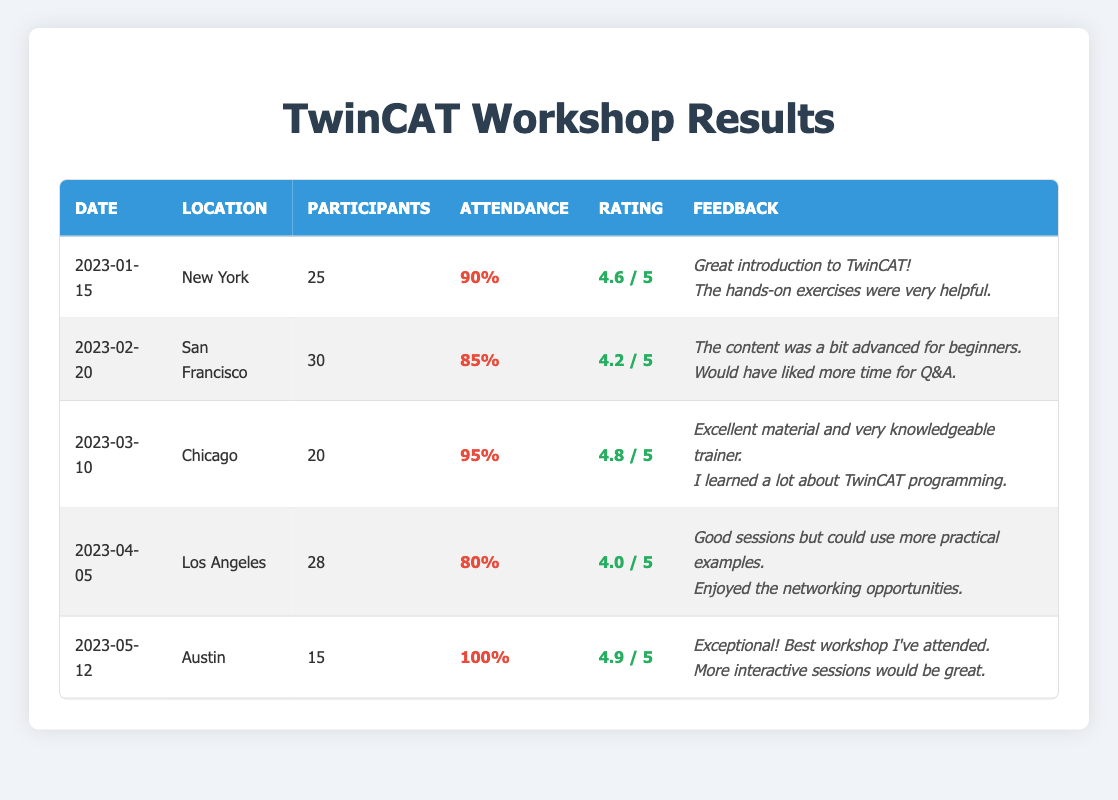What was the attendance rate for the workshop held in New York? The attendance rate for the New York workshop on January 15, 2023, is listed in the table as 90%.
Answer: 90% Which workshop had the highest average rating? The average ratings for each workshop are compared, and the Chicago workshop on March 10, 2023, has the highest rating of 4.8.
Answer: 4.8 How many participants attended the workshop in Austin? The table shows that the Austin workshop on May 12, 2023, had 15 participants.
Answer: 15 Is the attendance rate for the Los Angeles workshop higher than 80%? The attendance rate for the Los Angeles workshop is listed as 80%, which means it is not higher than 80%.
Answer: No What is the average rating of all the workshops combined? The ratings are as follows: 4.6, 4.2, 4.8, 4.0, and 4.9. The sum is 4.6 + 4.2 + 4.8 + 4.0 + 4.9 = 22.5. There are 5 workshops, so the average is 22.5 / 5 = 4.5.
Answer: 4.5 What percentage of the Austin workshop participants attended? The attendance rate for the Austin workshop is 100%, meaning all participants who registered attended the workshop.
Answer: 100% Which workshop had the least number of participants? The table shows that the Austin workshop had the least number of participants with only 15 attendees.
Answer: Austin How many feedback comments were provided for the Chicago workshop? The Chicago workshop has two feedback comments listed in the table.
Answer: 2 Was the feedback from the San Francisco workshop generally positive? The feedback from San Francisco included comments regarding the content being advanced for beginners and the desire for more Q&A time, indicating mixed feedback rather than purely positive remarks.
Answer: No If you were to rank the workshops by attendance rate, what would be the rank of the Chicago workshop? The attendance rates in order are: Austin (100%), Chicago (95%), New York (90%), San Francisco (85%), and Los Angeles (80%). Chicago is second in this ranking.
Answer: 2nd 